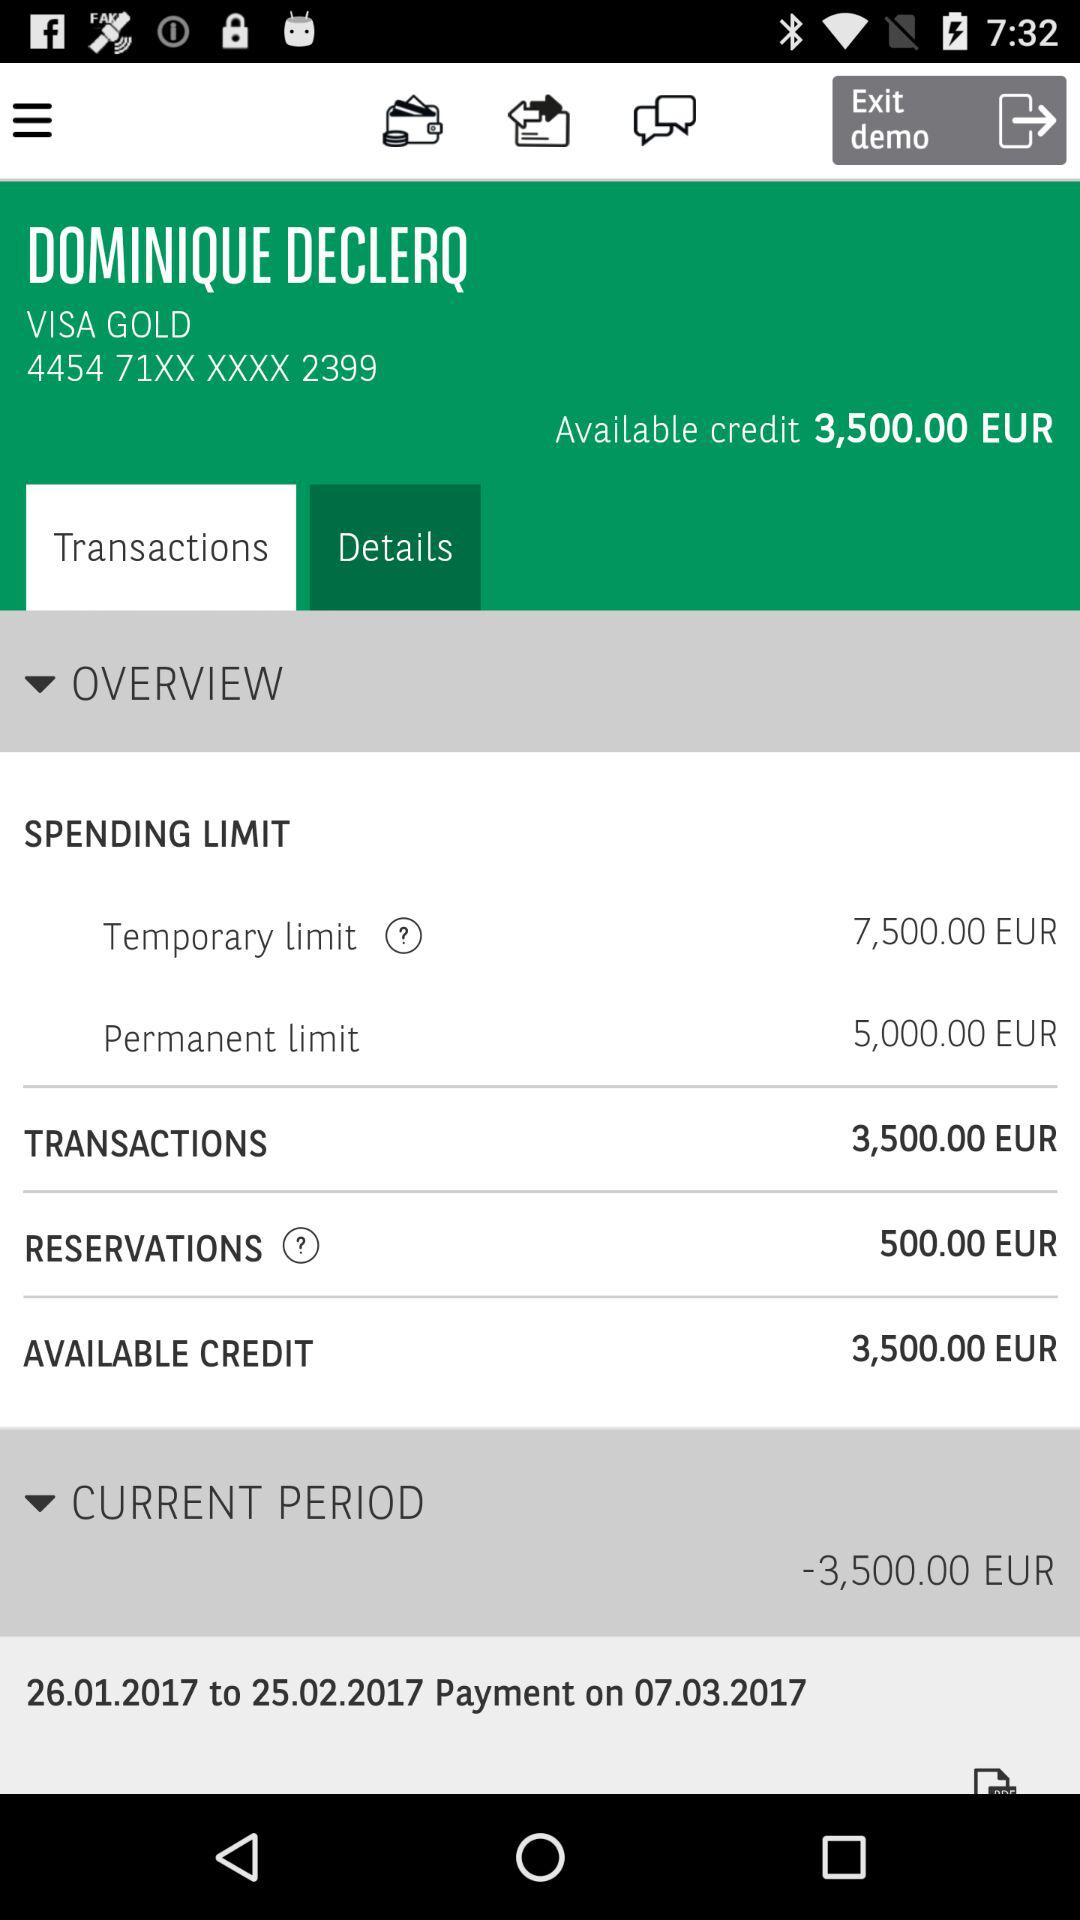What is the available credit? The available credit is 3,500 euros. 